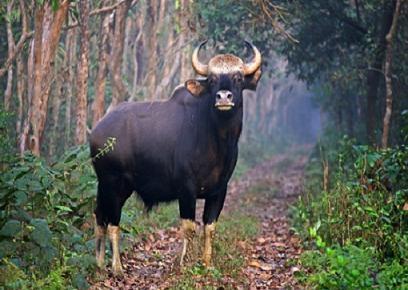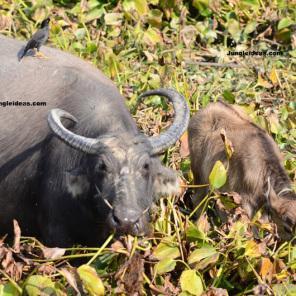The first image is the image on the left, the second image is the image on the right. Evaluate the accuracy of this statement regarding the images: "The left image contains one water buffalo looking directly at the camera, and the right image includes a water bufflao with a cord threaded through its nose.". Is it true? Answer yes or no. Yes. The first image is the image on the left, the second image is the image on the right. For the images shown, is this caption "there is at least on animal standing on a path" true? Answer yes or no. Yes. 